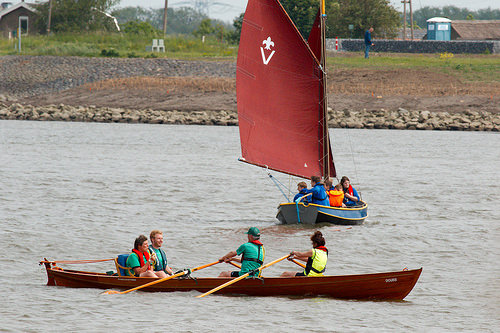<image>
Is there a man to the right of the woman? No. The man is not to the right of the woman. The horizontal positioning shows a different relationship. 